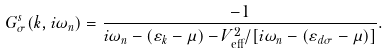<formula> <loc_0><loc_0><loc_500><loc_500>G ^ { s } _ { \sigma } ( { k } , i \omega _ { n } ) = \frac { - 1 } { i \omega _ { n } - ( \varepsilon _ { k } - \mu ) - V ^ { 2 } _ { \text {eff} } / [ i \omega _ { n } - ( \varepsilon _ { d \sigma } - \mu ) ] } .</formula> 